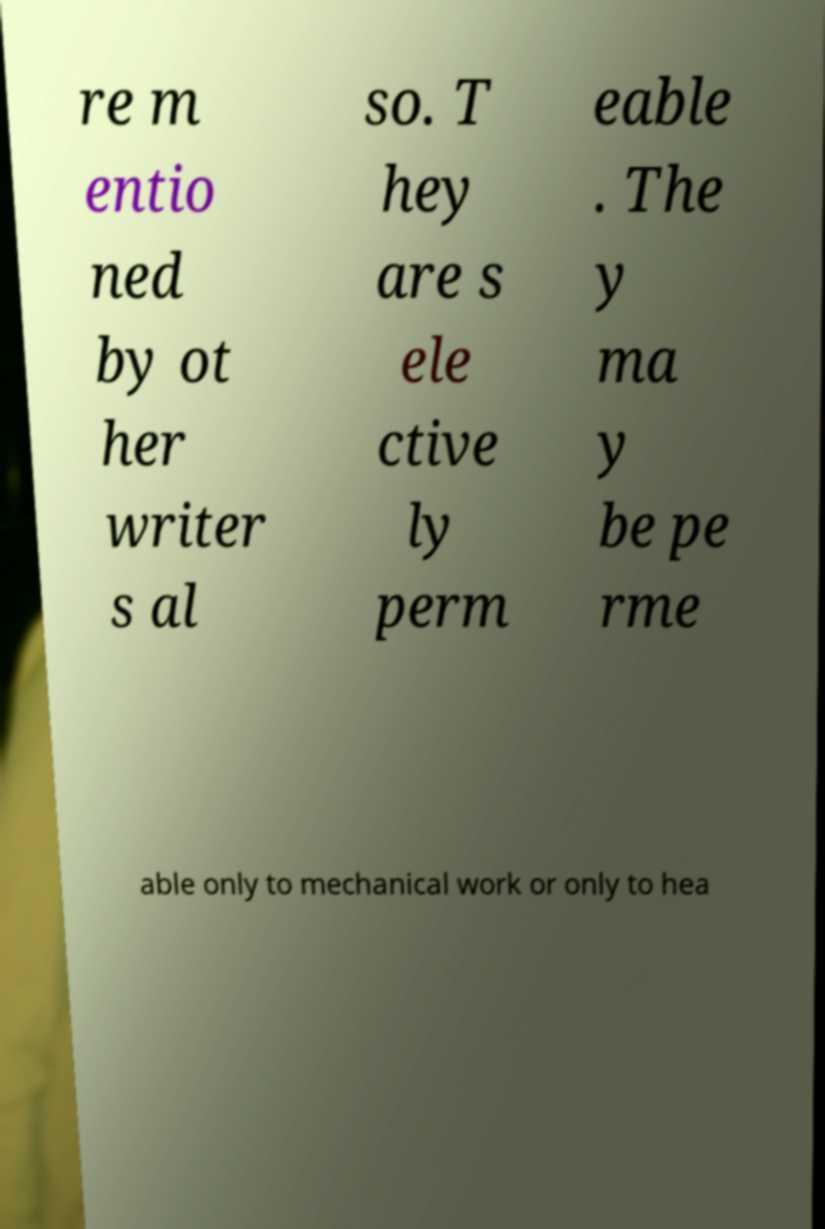I need the written content from this picture converted into text. Can you do that? re m entio ned by ot her writer s al so. T hey are s ele ctive ly perm eable . The y ma y be pe rme able only to mechanical work or only to hea 